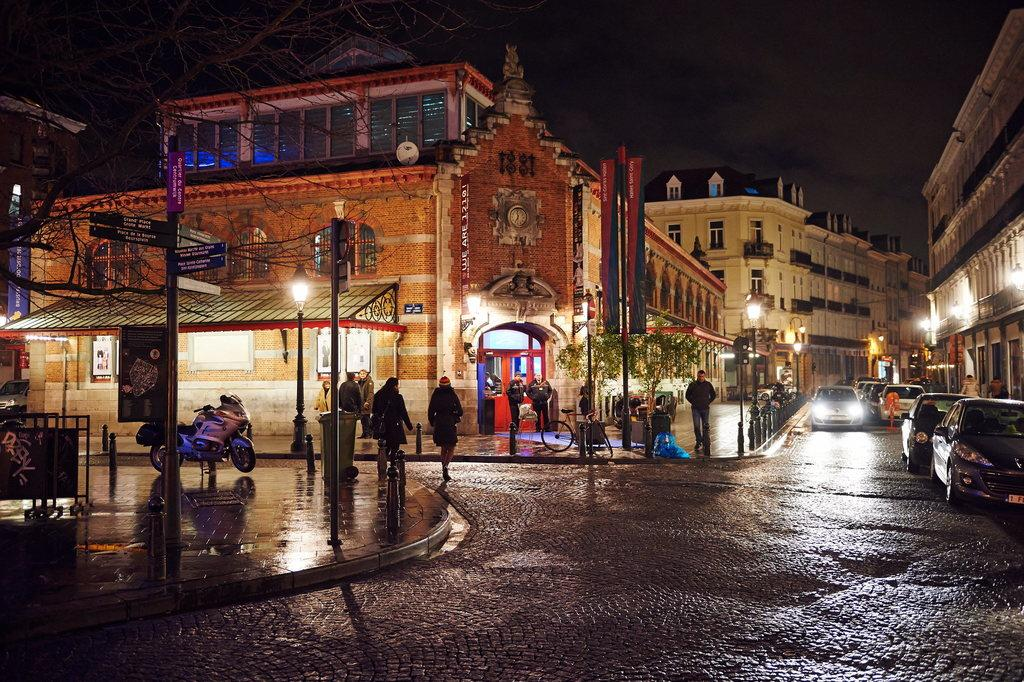What type of vehicles can be seen on the right side of the image? There are cars on the right side of the image. What are the people in the image doing? There are people walking in the middle of the image. What type of natural elements are present in the image? There are trees in the image. What type of man-made structures are present in the image? There are buildings in the image. What type of illumination is present in the image? There are lights in the image. What type of vehicle can be seen on the left side of the image? There is a motorcycle on the left side of the image. What type of curtain is hanging in the image? There is no curtain present in the image. What type of arm is visible in the image? There is no arm visible in the image. 